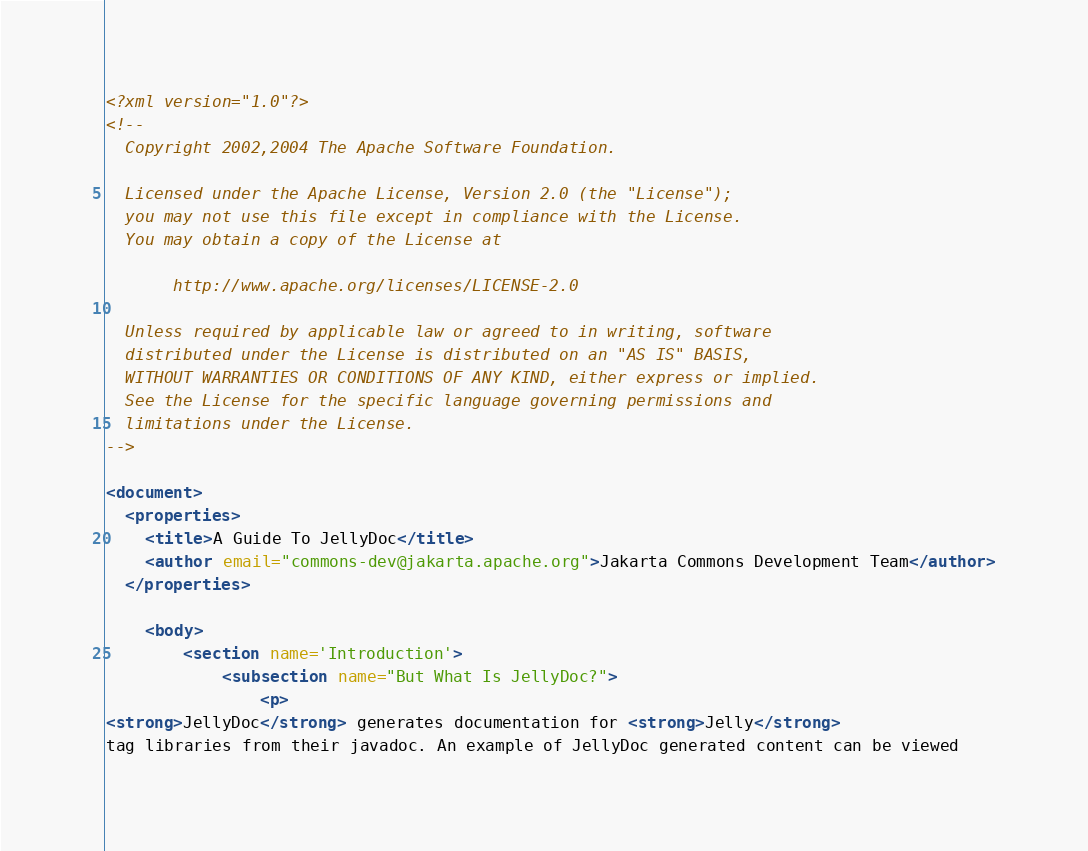Convert code to text. <code><loc_0><loc_0><loc_500><loc_500><_XML_><?xml version="1.0"?>
<!--
  Copyright 2002,2004 The Apache Software Foundation.
  
  Licensed under the Apache License, Version 2.0 (the "License");
  you may not use this file except in compliance with the License.
  You may obtain a copy of the License at
  
       http://www.apache.org/licenses/LICENSE-2.0
  
  Unless required by applicable law or agreed to in writing, software
  distributed under the License is distributed on an "AS IS" BASIS,
  WITHOUT WARRANTIES OR CONDITIONS OF ANY KIND, either express or implied.
  See the License for the specific language governing permissions and
  limitations under the License.
-->

<document>
  <properties>
    <title>A Guide To JellyDoc</title>
    <author email="commons-dev@jakarta.apache.org">Jakarta Commons Development Team</author>
  </properties>

    <body>
        <section name='Introduction'>
            <subsection name="But What Is JellyDoc?"> 
                <p>
<strong>JellyDoc</strong> generates documentation for <strong>Jelly</strong> 
tag libraries from their javadoc. An example of JellyDoc generated content can be viewed </code> 